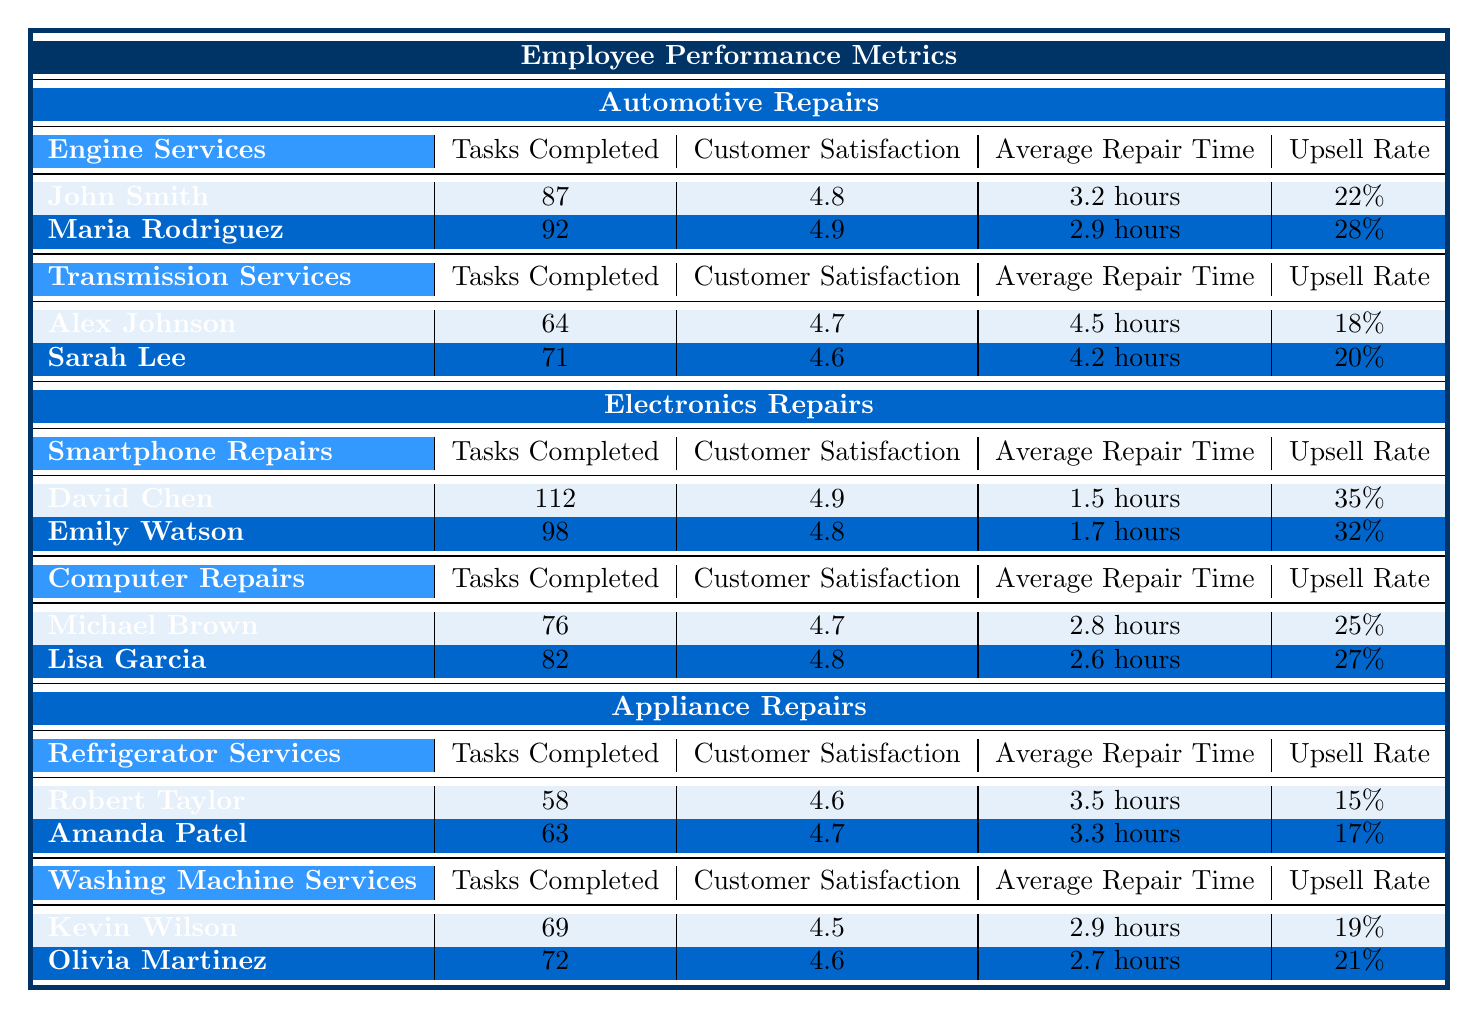What is the highest Customer Satisfaction rating among all employees? By examining the Customer Satisfaction ratings of each employee, Maria Rodriguez has the highest rating at 4.9.
Answer: 4.9 Which employee completed the most tasks in Smartphone Repairs? David Chen completed 112 tasks, which is more than any other employee in the Smartphone Repairs category.
Answer: David Chen What is the average repair time for Washing Machine Services? The average repair times for Kevin Wilson and Olivia Martinez are 2.9 hours and 2.7 hours, respectively. The average is (2.9 + 2.7) / 2 = 2.8 hours.
Answer: 2.8 hours Who has the highest Upsell Rate in Transmission Services? Among Alex Johnson (18%) and Sarah Lee (20%), Sarah Lee has the highest Upsell Rate at 20%.
Answer: Sarah Lee What is the total number of Tasks Completed by all employees in Appliance Repairs? Adding the tasks completed by all Appliance Repair employees: 58 (Robert Taylor) + 63 (Amanda Patel) + 69 (Kevin Wilson) + 72 (Olivia Martinez) = 262 tasks.
Answer: 262 Is there any employee with a Customer Satisfaction rating below 4.5? Checking the ratings, Kevin Wilson has a Customer Satisfaction rating of 4.5, and Robert Taylor has a rating of 4.6, so no employees have a rating below 4.5.
Answer: No Which category has the best average Upsell Rate and what is it? Calculating the average Upsell Rates: Automotive Repairs = (22% + 28%) / 2 = 25%, Electronics Repairs = (35% + 32%) / 2 = 33.5%, Appliance Repairs = (15% + 17% + 19% + 21%) / 4 = 18%. Electronics Repairs has the highest average Upsell Rate of 33.5%.
Answer: Electronics Repairs at 33.5% How many tasks did the top two performers complete in Engine Services combined? John Smith completed 87 tasks, and Maria Rodriguez completed 92 tasks. The total is 87 + 92 = 179 tasks.
Answer: 179 Who performed better in terms of Tasks Completed, Michael Brown or Lisa Garcia? Michael Brown completed 76 tasks, while Lisa Garcia completed 82 tasks. Lisa Garcia has completed more tasks.
Answer: Lisa Garcia Is there a correlation between Average Repair Time and Customer Satisfaction in Automotive Repairs? Comparing the Average Repair Times (3.2 hours for John Smith and 2.9 hours for Maria Rodriguez) with their Customer Satisfaction ratings (4.8 for both), shorter repair times correspond to higher satisfaction in this instance.
Answer: Yes, shorter time correlates with higher satisfaction for these two 